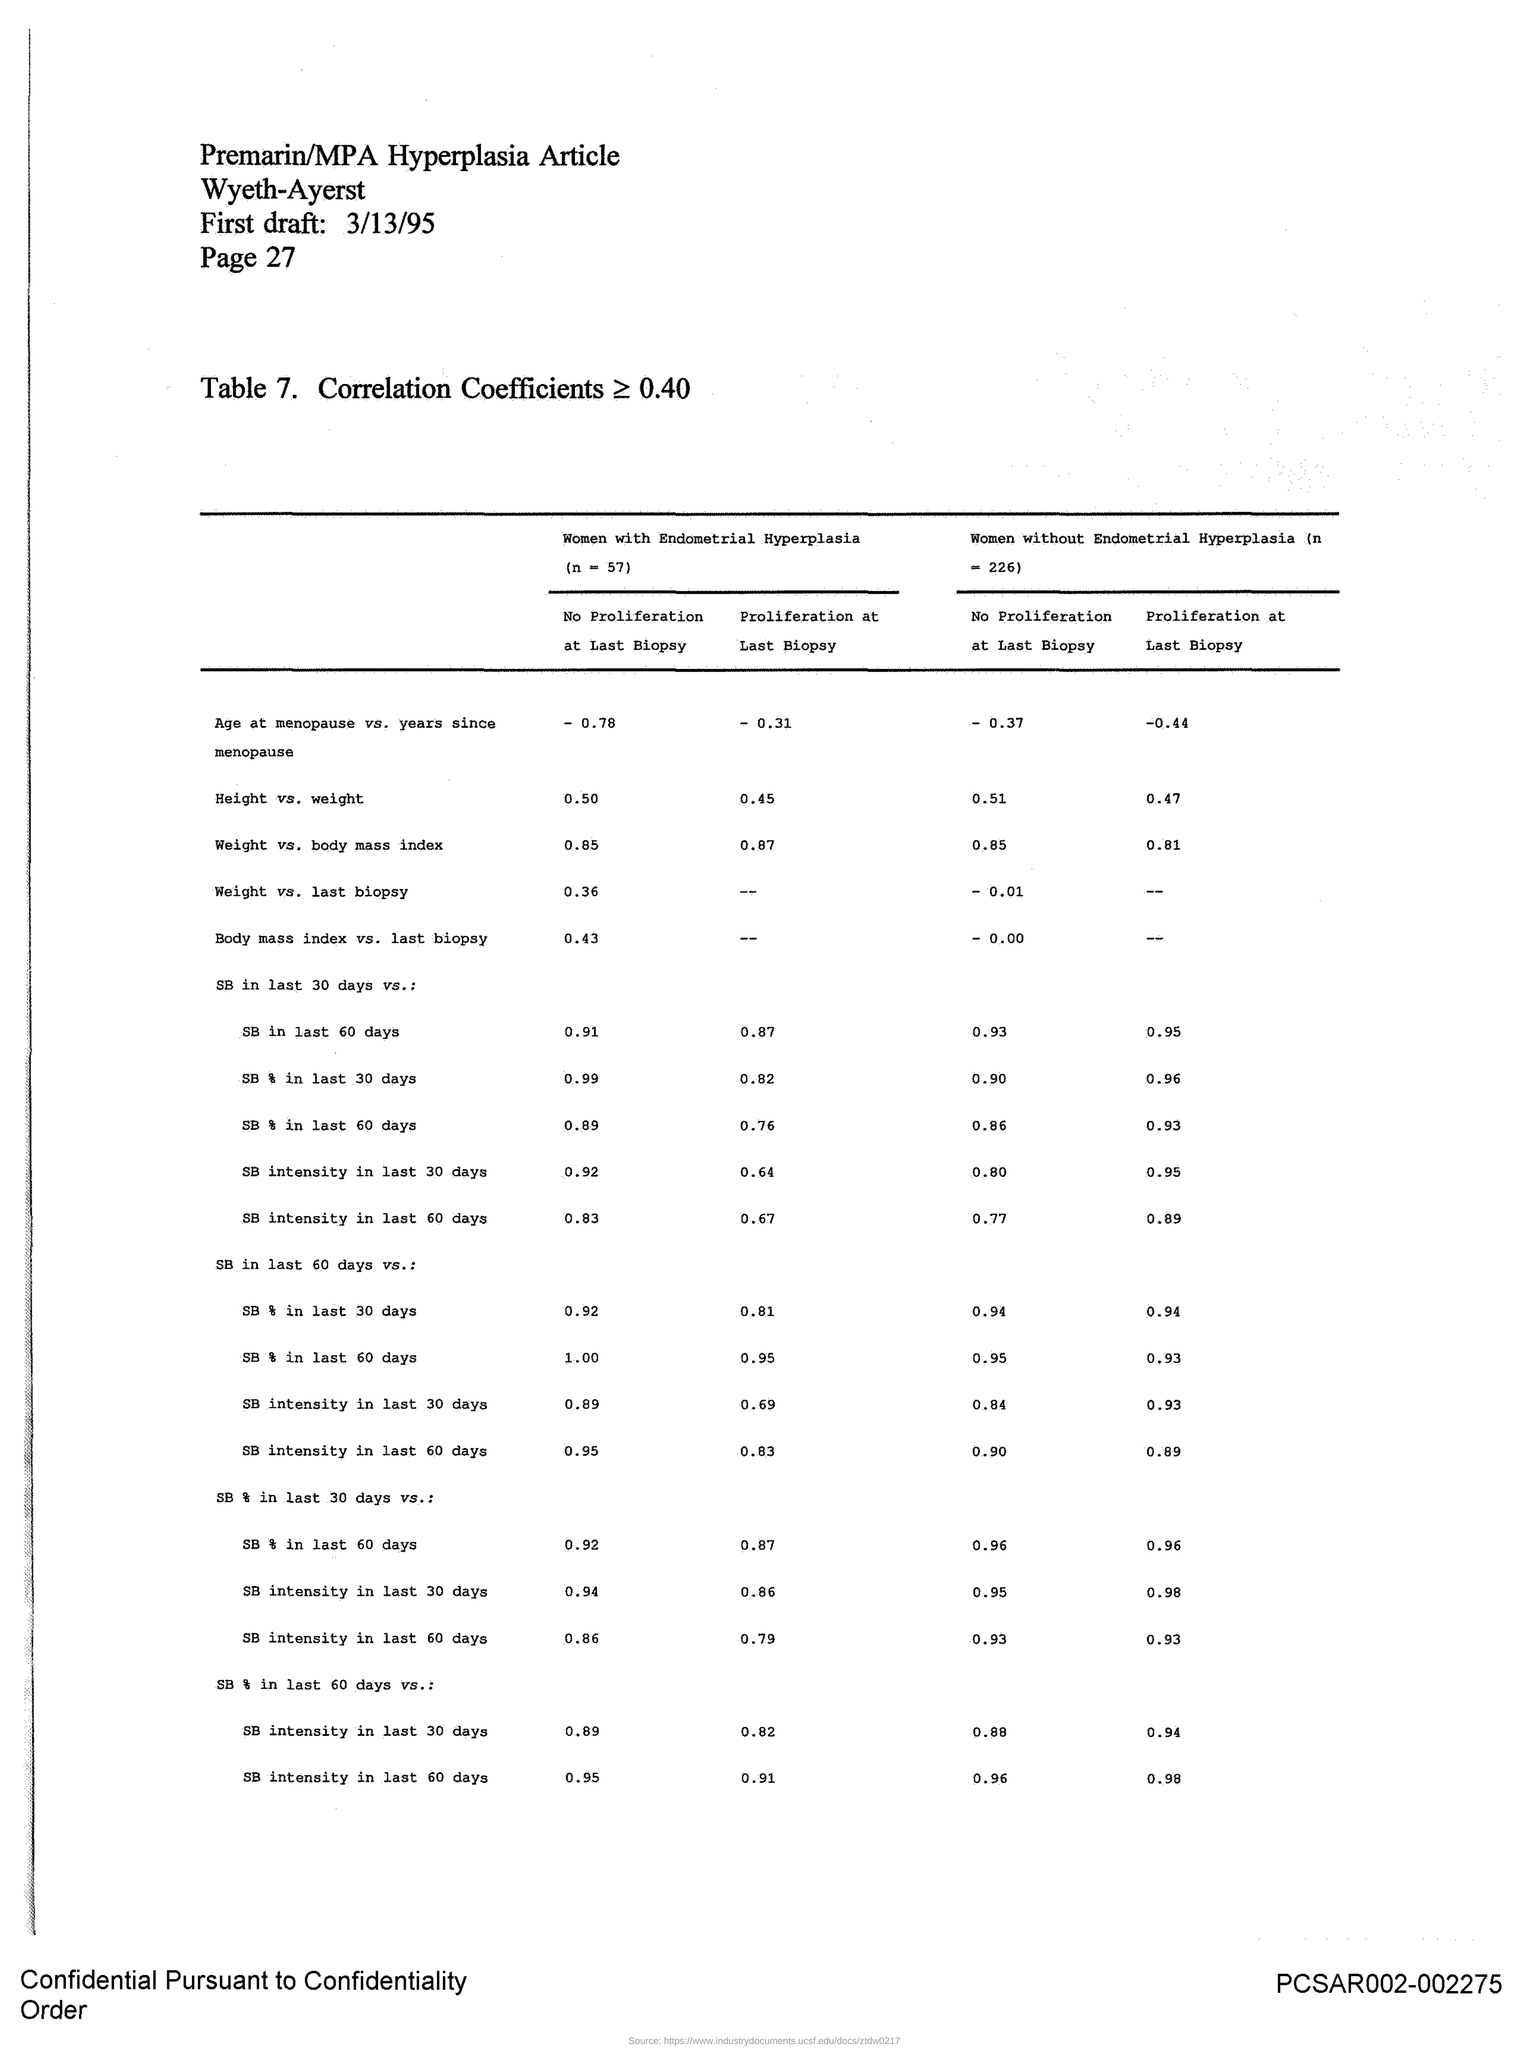List a handful of essential elements in this visual. The first draft date provided in the document is 3/13/95. The page number mentioned in this document is 27. 